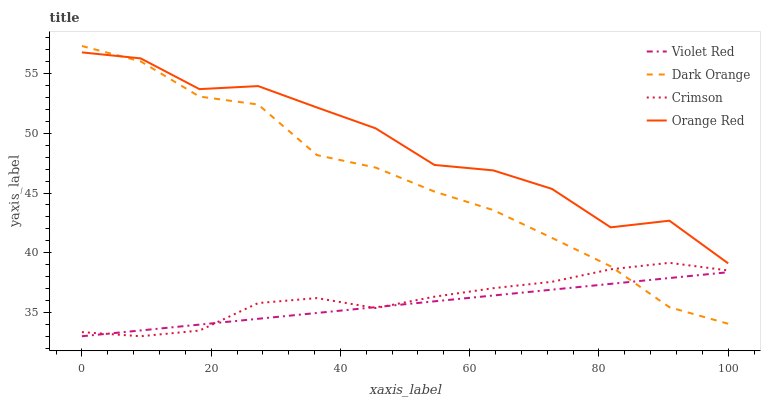Does Dark Orange have the minimum area under the curve?
Answer yes or no. No. Does Dark Orange have the maximum area under the curve?
Answer yes or no. No. Is Dark Orange the smoothest?
Answer yes or no. No. Is Dark Orange the roughest?
Answer yes or no. No. Does Dark Orange have the lowest value?
Answer yes or no. No. Does Violet Red have the highest value?
Answer yes or no. No. Is Violet Red less than Orange Red?
Answer yes or no. Yes. Is Orange Red greater than Violet Red?
Answer yes or no. Yes. Does Violet Red intersect Orange Red?
Answer yes or no. No. 